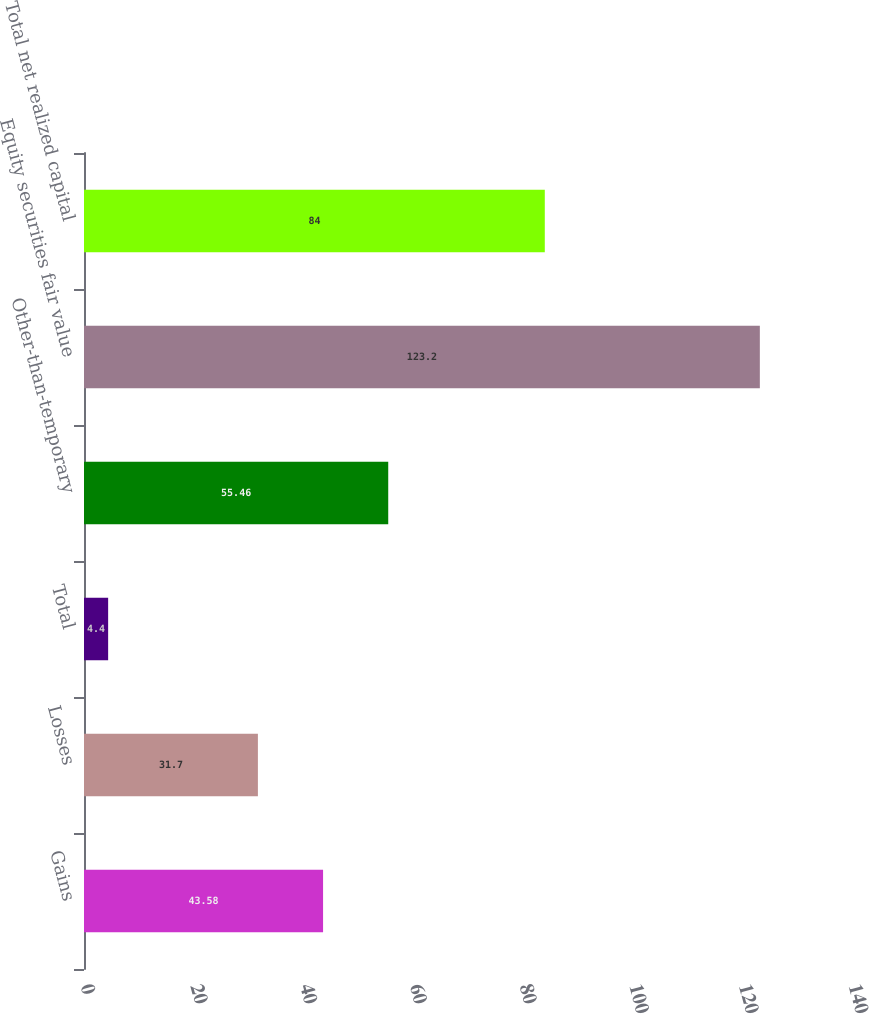<chart> <loc_0><loc_0><loc_500><loc_500><bar_chart><fcel>Gains<fcel>Losses<fcel>Total<fcel>Other-than-temporary<fcel>Equity securities fair value<fcel>Total net realized capital<nl><fcel>43.58<fcel>31.7<fcel>4.4<fcel>55.46<fcel>123.2<fcel>84<nl></chart> 